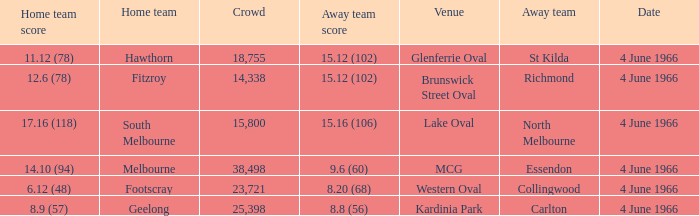What is the average crowd size of the away team who scored 9.6 (60)? 38498.0. 